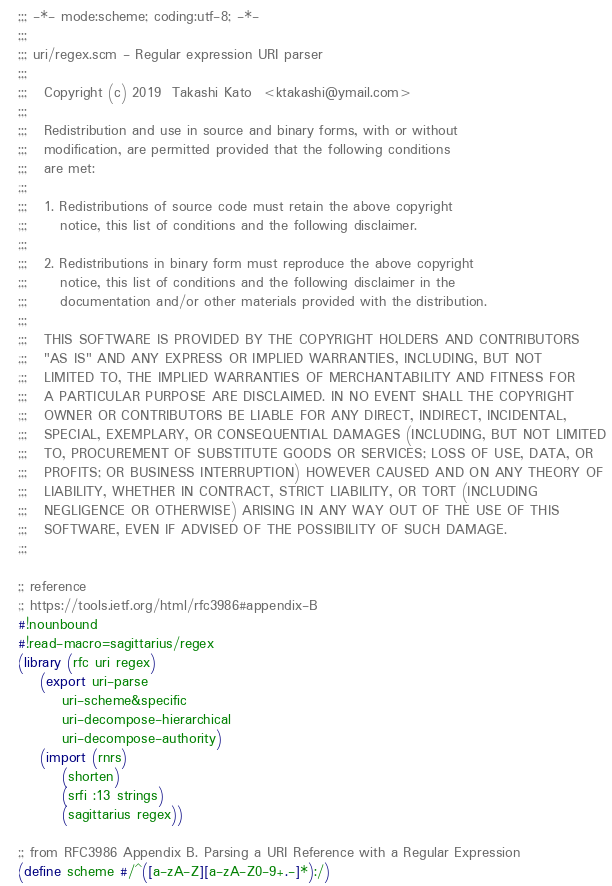<code> <loc_0><loc_0><loc_500><loc_500><_Scheme_>;;; -*- mode:scheme; coding:utf-8; -*-
;;;
;;; uri/regex.scm - Regular expression URI parser
;;;  
;;;   Copyright (c) 2019  Takashi Kato  <ktakashi@ymail.com>
;;;   
;;;   Redistribution and use in source and binary forms, with or without
;;;   modification, are permitted provided that the following conditions
;;;   are met:
;;;   
;;;   1. Redistributions of source code must retain the above copyright
;;;      notice, this list of conditions and the following disclaimer.
;;;  
;;;   2. Redistributions in binary form must reproduce the above copyright
;;;      notice, this list of conditions and the following disclaimer in the
;;;      documentation and/or other materials provided with the distribution.
;;;  
;;;   THIS SOFTWARE IS PROVIDED BY THE COPYRIGHT HOLDERS AND CONTRIBUTORS
;;;   "AS IS" AND ANY EXPRESS OR IMPLIED WARRANTIES, INCLUDING, BUT NOT
;;;   LIMITED TO, THE IMPLIED WARRANTIES OF MERCHANTABILITY AND FITNESS FOR
;;;   A PARTICULAR PURPOSE ARE DISCLAIMED. IN NO EVENT SHALL THE COPYRIGHT
;;;   OWNER OR CONTRIBUTORS BE LIABLE FOR ANY DIRECT, INDIRECT, INCIDENTAL,
;;;   SPECIAL, EXEMPLARY, OR CONSEQUENTIAL DAMAGES (INCLUDING, BUT NOT LIMITED
;;;   TO, PROCUREMENT OF SUBSTITUTE GOODS OR SERVICES; LOSS OF USE, DATA, OR
;;;   PROFITS; OR BUSINESS INTERRUPTION) HOWEVER CAUSED AND ON ANY THEORY OF
;;;   LIABILITY, WHETHER IN CONTRACT, STRICT LIABILITY, OR TORT (INCLUDING
;;;   NEGLIGENCE OR OTHERWISE) ARISING IN ANY WAY OUT OF THE USE OF THIS
;;;   SOFTWARE, EVEN IF ADVISED OF THE POSSIBILITY OF SUCH DAMAGE.
;;;  

;; reference
;; https://tools.ietf.org/html/rfc3986#appendix-B
#!nounbound
#!read-macro=sagittarius/regex
(library (rfc uri regex)
    (export uri-parse
	    uri-scheme&specific
	    uri-decompose-hierarchical
	    uri-decompose-authority)
    (import (rnrs)
	    (shorten)
	    (srfi :13 strings)
	    (sagittarius regex))

;; from RFC3986 Appendix B. Parsing a URI Reference with a Regular Expression
(define scheme #/^([a-zA-Z][a-zA-Z0-9+.-]*):/)</code> 